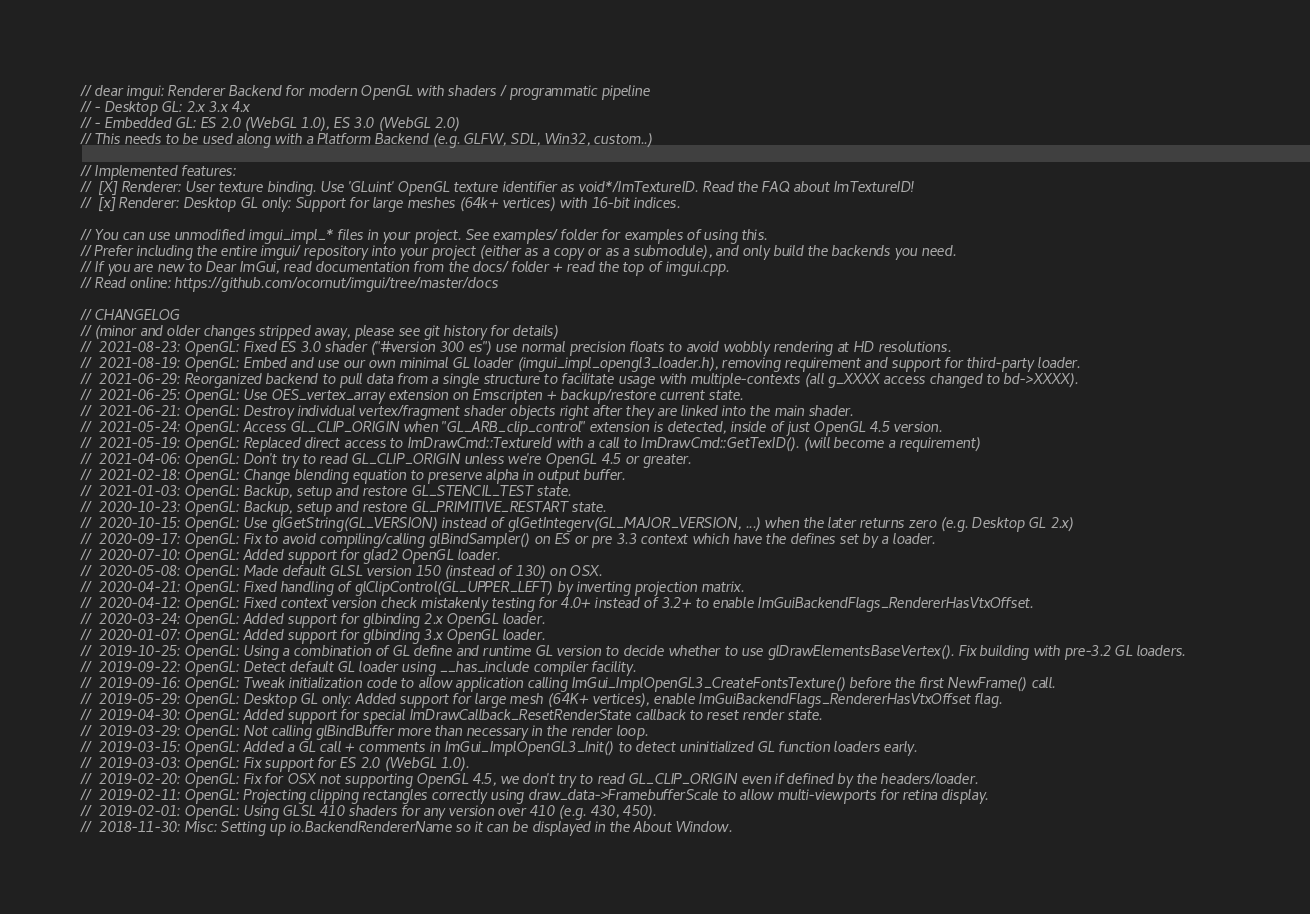<code> <loc_0><loc_0><loc_500><loc_500><_C++_>// dear imgui: Renderer Backend for modern OpenGL with shaders / programmatic pipeline
// - Desktop GL: 2.x 3.x 4.x
// - Embedded GL: ES 2.0 (WebGL 1.0), ES 3.0 (WebGL 2.0)
// This needs to be used along with a Platform Backend (e.g. GLFW, SDL, Win32, custom..)

// Implemented features:
//  [X] Renderer: User texture binding. Use 'GLuint' OpenGL texture identifier as void*/ImTextureID. Read the FAQ about ImTextureID!
//  [x] Renderer: Desktop GL only: Support for large meshes (64k+ vertices) with 16-bit indices.

// You can use unmodified imgui_impl_* files in your project. See examples/ folder for examples of using this.
// Prefer including the entire imgui/ repository into your project (either as a copy or as a submodule), and only build the backends you need.
// If you are new to Dear ImGui, read documentation from the docs/ folder + read the top of imgui.cpp.
// Read online: https://github.com/ocornut/imgui/tree/master/docs

// CHANGELOG
// (minor and older changes stripped away, please see git history for details)
//  2021-08-23: OpenGL: Fixed ES 3.0 shader ("#version 300 es") use normal precision floats to avoid wobbly rendering at HD resolutions.
//  2021-08-19: OpenGL: Embed and use our own minimal GL loader (imgui_impl_opengl3_loader.h), removing requirement and support for third-party loader.
//  2021-06-29: Reorganized backend to pull data from a single structure to facilitate usage with multiple-contexts (all g_XXXX access changed to bd->XXXX).
//  2021-06-25: OpenGL: Use OES_vertex_array extension on Emscripten + backup/restore current state.
//  2021-06-21: OpenGL: Destroy individual vertex/fragment shader objects right after they are linked into the main shader.
//  2021-05-24: OpenGL: Access GL_CLIP_ORIGIN when "GL_ARB_clip_control" extension is detected, inside of just OpenGL 4.5 version.
//  2021-05-19: OpenGL: Replaced direct access to ImDrawCmd::TextureId with a call to ImDrawCmd::GetTexID(). (will become a requirement)
//  2021-04-06: OpenGL: Don't try to read GL_CLIP_ORIGIN unless we're OpenGL 4.5 or greater.
//  2021-02-18: OpenGL: Change blending equation to preserve alpha in output buffer.
//  2021-01-03: OpenGL: Backup, setup and restore GL_STENCIL_TEST state.
//  2020-10-23: OpenGL: Backup, setup and restore GL_PRIMITIVE_RESTART state.
//  2020-10-15: OpenGL: Use glGetString(GL_VERSION) instead of glGetIntegerv(GL_MAJOR_VERSION, ...) when the later returns zero (e.g. Desktop GL 2.x)
//  2020-09-17: OpenGL: Fix to avoid compiling/calling glBindSampler() on ES or pre 3.3 context which have the defines set by a loader.
//  2020-07-10: OpenGL: Added support for glad2 OpenGL loader.
//  2020-05-08: OpenGL: Made default GLSL version 150 (instead of 130) on OSX.
//  2020-04-21: OpenGL: Fixed handling of glClipControl(GL_UPPER_LEFT) by inverting projection matrix.
//  2020-04-12: OpenGL: Fixed context version check mistakenly testing for 4.0+ instead of 3.2+ to enable ImGuiBackendFlags_RendererHasVtxOffset.
//  2020-03-24: OpenGL: Added support for glbinding 2.x OpenGL loader.
//  2020-01-07: OpenGL: Added support for glbinding 3.x OpenGL loader.
//  2019-10-25: OpenGL: Using a combination of GL define and runtime GL version to decide whether to use glDrawElementsBaseVertex(). Fix building with pre-3.2 GL loaders.
//  2019-09-22: OpenGL: Detect default GL loader using __has_include compiler facility.
//  2019-09-16: OpenGL: Tweak initialization code to allow application calling ImGui_ImplOpenGL3_CreateFontsTexture() before the first NewFrame() call.
//  2019-05-29: OpenGL: Desktop GL only: Added support for large mesh (64K+ vertices), enable ImGuiBackendFlags_RendererHasVtxOffset flag.
//  2019-04-30: OpenGL: Added support for special ImDrawCallback_ResetRenderState callback to reset render state.
//  2019-03-29: OpenGL: Not calling glBindBuffer more than necessary in the render loop.
//  2019-03-15: OpenGL: Added a GL call + comments in ImGui_ImplOpenGL3_Init() to detect uninitialized GL function loaders early.
//  2019-03-03: OpenGL: Fix support for ES 2.0 (WebGL 1.0).
//  2019-02-20: OpenGL: Fix for OSX not supporting OpenGL 4.5, we don't try to read GL_CLIP_ORIGIN even if defined by the headers/loader.
//  2019-02-11: OpenGL: Projecting clipping rectangles correctly using draw_data->FramebufferScale to allow multi-viewports for retina display.
//  2019-02-01: OpenGL: Using GLSL 410 shaders for any version over 410 (e.g. 430, 450).
//  2018-11-30: Misc: Setting up io.BackendRendererName so it can be displayed in the About Window.</code> 